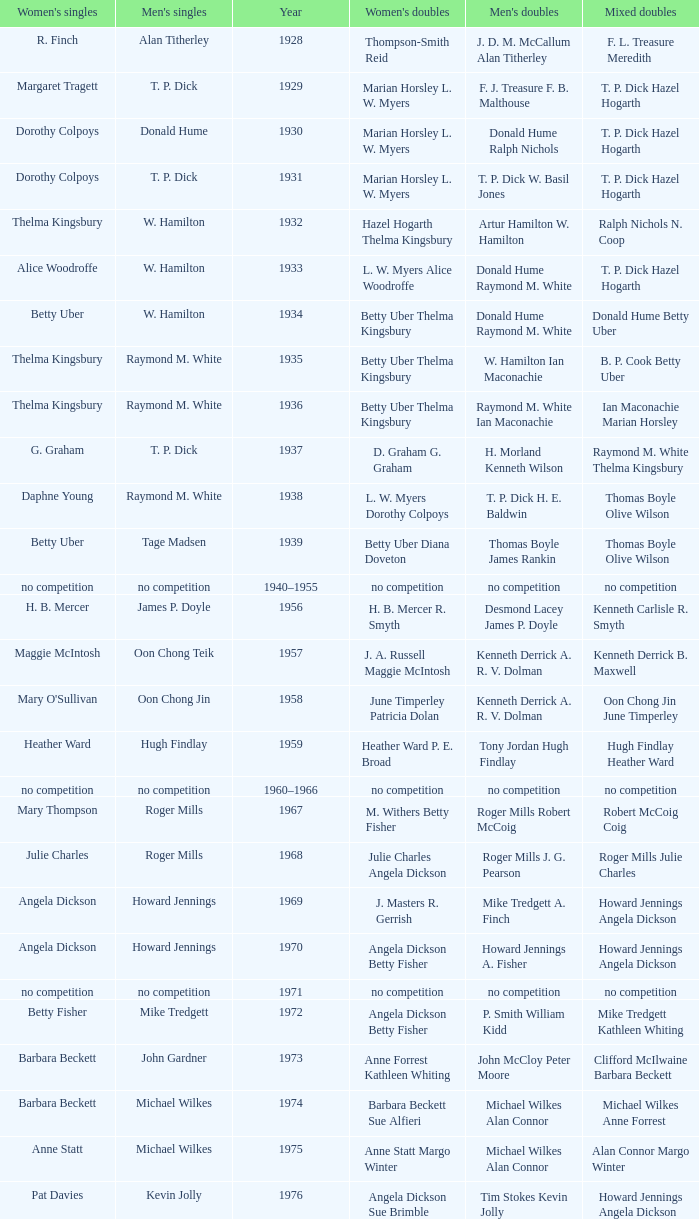Who won the Women's doubles in the year that David Eddy Eddy Sutton won the Men's doubles, and that David Eddy won the Men's singles? Anne Statt Jane Webster. Could you help me parse every detail presented in this table? {'header': ["Women's singles", "Men's singles", 'Year', "Women's doubles", "Men's doubles", 'Mixed doubles'], 'rows': [['R. Finch', 'Alan Titherley', '1928', 'Thompson-Smith Reid', 'J. D. M. McCallum Alan Titherley', 'F. L. Treasure Meredith'], ['Margaret Tragett', 'T. P. Dick', '1929', 'Marian Horsley L. W. Myers', 'F. J. Treasure F. B. Malthouse', 'T. P. Dick Hazel Hogarth'], ['Dorothy Colpoys', 'Donald Hume', '1930', 'Marian Horsley L. W. Myers', 'Donald Hume Ralph Nichols', 'T. P. Dick Hazel Hogarth'], ['Dorothy Colpoys', 'T. P. Dick', '1931', 'Marian Horsley L. W. Myers', 'T. P. Dick W. Basil Jones', 'T. P. Dick Hazel Hogarth'], ['Thelma Kingsbury', 'W. Hamilton', '1932', 'Hazel Hogarth Thelma Kingsbury', 'Artur Hamilton W. Hamilton', 'Ralph Nichols N. Coop'], ['Alice Woodroffe', 'W. Hamilton', '1933', 'L. W. Myers Alice Woodroffe', 'Donald Hume Raymond M. White', 'T. P. Dick Hazel Hogarth'], ['Betty Uber', 'W. Hamilton', '1934', 'Betty Uber Thelma Kingsbury', 'Donald Hume Raymond M. White', 'Donald Hume Betty Uber'], ['Thelma Kingsbury', 'Raymond M. White', '1935', 'Betty Uber Thelma Kingsbury', 'W. Hamilton Ian Maconachie', 'B. P. Cook Betty Uber'], ['Thelma Kingsbury', 'Raymond M. White', '1936', 'Betty Uber Thelma Kingsbury', 'Raymond M. White Ian Maconachie', 'Ian Maconachie Marian Horsley'], ['G. Graham', 'T. P. Dick', '1937', 'D. Graham G. Graham', 'H. Morland Kenneth Wilson', 'Raymond M. White Thelma Kingsbury'], ['Daphne Young', 'Raymond M. White', '1938', 'L. W. Myers Dorothy Colpoys', 'T. P. Dick H. E. Baldwin', 'Thomas Boyle Olive Wilson'], ['Betty Uber', 'Tage Madsen', '1939', 'Betty Uber Diana Doveton', 'Thomas Boyle James Rankin', 'Thomas Boyle Olive Wilson'], ['no competition', 'no competition', '1940–1955', 'no competition', 'no competition', 'no competition'], ['H. B. Mercer', 'James P. Doyle', '1956', 'H. B. Mercer R. Smyth', 'Desmond Lacey James P. Doyle', 'Kenneth Carlisle R. Smyth'], ['Maggie McIntosh', 'Oon Chong Teik', '1957', 'J. A. Russell Maggie McIntosh', 'Kenneth Derrick A. R. V. Dolman', 'Kenneth Derrick B. Maxwell'], ["Mary O'Sullivan", 'Oon Chong Jin', '1958', 'June Timperley Patricia Dolan', 'Kenneth Derrick A. R. V. Dolman', 'Oon Chong Jin June Timperley'], ['Heather Ward', 'Hugh Findlay', '1959', 'Heather Ward P. E. Broad', 'Tony Jordan Hugh Findlay', 'Hugh Findlay Heather Ward'], ['no competition', 'no competition', '1960–1966', 'no competition', 'no competition', 'no competition'], ['Mary Thompson', 'Roger Mills', '1967', 'M. Withers Betty Fisher', 'Roger Mills Robert McCoig', 'Robert McCoig Coig'], ['Julie Charles', 'Roger Mills', '1968', 'Julie Charles Angela Dickson', 'Roger Mills J. G. Pearson', 'Roger Mills Julie Charles'], ['Angela Dickson', 'Howard Jennings', '1969', 'J. Masters R. Gerrish', 'Mike Tredgett A. Finch', 'Howard Jennings Angela Dickson'], ['Angela Dickson', 'Howard Jennings', '1970', 'Angela Dickson Betty Fisher', 'Howard Jennings A. Fisher', 'Howard Jennings Angela Dickson'], ['no competition', 'no competition', '1971', 'no competition', 'no competition', 'no competition'], ['Betty Fisher', 'Mike Tredgett', '1972', 'Angela Dickson Betty Fisher', 'P. Smith William Kidd', 'Mike Tredgett Kathleen Whiting'], ['Barbara Beckett', 'John Gardner', '1973', 'Anne Forrest Kathleen Whiting', 'John McCloy Peter Moore', 'Clifford McIlwaine Barbara Beckett'], ['Barbara Beckett', 'Michael Wilkes', '1974', 'Barbara Beckett Sue Alfieri', 'Michael Wilkes Alan Connor', 'Michael Wilkes Anne Forrest'], ['Anne Statt', 'Michael Wilkes', '1975', 'Anne Statt Margo Winter', 'Michael Wilkes Alan Connor', 'Alan Connor Margo Winter'], ['Pat Davies', 'Kevin Jolly', '1976', 'Angela Dickson Sue Brimble', 'Tim Stokes Kevin Jolly', 'Howard Jennings Angela Dickson'], ['Paula Kilvington', 'David Eddy', '1977', 'Anne Statt Jane Webster', 'David Eddy Eddy Sutton', 'David Eddy Barbara Giles'], ['Gillian Gilks', 'Mike Tredgett', '1978', 'Barbara Sutton Marjan Ridder', 'David Eddy Eddy Sutton', 'Elliot Stuart Gillian Gilks'], ['Nora Perry', 'Kevin Jolly', '1979', 'Barbara Sutton Nora Perry', 'Ray Stevens Mike Tredgett', 'Mike Tredgett Nora Perry'], ['Jane Webster', 'Thomas Kihlström', '1980', 'Jane Webster Karen Puttick', 'Thomas Kihlström Bengt Fröman', 'Billy Gilliland Karen Puttick'], ['Gillian Gilks', 'Ray Stevens', '1981', 'Gillian Gilks Paula Kilvington', 'Ray Stevens Mike Tredgett', 'Mike Tredgett Nora Perry'], ['Karen Bridge', 'Steve Baddeley', '1982', 'Karen Chapman Sally Podger', 'David Eddy Eddy Sutton', 'Billy Gilliland Karen Chapman'], ['Sally Podger', 'Steve Butler', '1983', 'Nora Perry Jane Webster', 'Mike Tredgett Dipak Tailor', 'Dipak Tailor Nora Perry'], ['Karen Beckman', 'Steve Butler', '1984', 'Helen Troke Karen Chapman', 'Mike Tredgett Martin Dew', 'Mike Tredgett Karen Chapman'], ['Charlotte Hattens', 'Morten Frost', '1985', 'Gillian Gilks Helen Troke', 'Billy Gilliland Dan Travers', 'Martin Dew Gillian Gilks'], ['Fiona Elliott', 'Darren Hall', '1986', 'Karen Beckman Sara Halsall', 'Martin Dew Dipak Tailor', 'Jesper Knudsen Nettie Nielsen'], ['Fiona Elliott', 'Darren Hall', '1987', 'Karen Beckman Sara Halsall', 'Martin Dew Darren Hall', 'Martin Dew Gillian Gilks'], ['Lee Jung-mi', 'Vimal Kumar', '1988', 'Fiona Elliott Sara Halsall', 'Richard Outterside Mike Brown', 'Martin Dew Gillian Gilks'], ['Bang Soo-hyun', 'Darren Hall', '1989', 'Karen Beckman Sara Sankey', 'Nick Ponting Dave Wright', 'Mike Brown Jillian Wallwork'], ['Joanne Muggeridge', 'Mathew Smith', '1990', 'Karen Chapman Sara Sankey', 'Nick Ponting Dave Wright', 'Dave Wright Claire Palmer'], ['Denyse Julien', 'Vimal Kumar', '1991', 'Cheryl Johnson Julie Bradbury', 'Nick Ponting Dave Wright', 'Nick Ponting Joanne Wright'], ['Fiona Smith', 'Wei Yan', '1992', 'Denyse Julien Doris Piché', 'Michael Adams Chris Rees', 'Andy Goode Joanne Wright'], ['Sue Louis Lane', 'Anders Nielsen', '1993', 'Julie Bradbury Sara Sankey', 'Nick Ponting Dave Wright', 'Nick Ponting Joanne Wright'], ['Marina Andrievskaya', 'Darren Hall', '1994', 'Julie Bradbury Joanne Wright', 'Michael Adams Simon Archer', 'Chris Hunt Joanne Wright'], ['Denyse Julien', 'Peter Rasmussen', '1995', 'Julie Bradbury Joanne Wright', 'Andrei Andropov Nikolai Zuyev', 'Nick Ponting Joanne Wright'], ['Elena Rybkina', 'Colin Haughton', '1996', 'Elena Rybkina Marina Yakusheva', 'Andrei Andropov Nikolai Zuyev', 'Nikolai Zuyev Marina Yakusheva'], ['Kelly Morgan', 'Chris Bruil', '1997', 'Nicole van Hooren Brenda Conijn', 'Ian Pearson James Anderson', 'Quinten van Dalm Nicole van Hooren'], ['Brenda Beenhakker', 'Dicky Palyama', '1998', 'Sara Sankey Ella Tripp', 'James Anderson Ian Sullivan', 'James Anderson Sara Sankey'], ['Marina Andrievskaya', 'Daniel Eriksson', '1999', 'Marina Andrievskaya Catrine Bengtsson', 'Joachim Tesche Jean-Philippe Goyette', 'Henrik Andersson Marina Andrievskaya'], ['Marina Yakusheva', 'Richard Vaughan', '2000', 'Irina Ruslyakova Marina Yakusheva', 'Joachim Andersson Peter Axelsson', 'Peter Jeffrey Joanne Davies'], ['Brenda Beenhakker', 'Irwansyah', '2001', 'Sara Sankey Ella Tripp', 'Vincent Laigle Svetoslav Stoyanov', 'Nikolai Zuyev Marina Yakusheva'], ['Karina de Wit', 'Irwansyah', '2002', 'Ella Tripp Joanne Wright', 'Nikolai Zuyev Stanislav Pukhov', 'Nikolai Zuyev Marina Yakusheva'], ['Ella Karachkova', 'Irwansyah', '2003', 'Ella Karachkova Anastasia Russkikh', 'Ashley Thilthorpe Kristian Roebuck', 'Alexandr Russkikh Anastasia Russkikh'], ['Petya Nedelcheva', 'Nathan Rice', '2004', 'Petya Nedelcheva Yuan Wemyss', 'Reuben Gordown Aji Basuki Sindoro', 'Matthew Hughes Kelly Morgan'], ['Eleanor Cox', 'Chetan Anand', '2005', 'Hayley Connor Heather Olver', 'Andrew Ellis Dean George', 'Valiyaveetil Diju Jwala Gutta'], ['Huang Chia-chi', 'Irwansyah', '2006', 'Natalie Munt Mariana Agathangelou', 'Matthew Hughes Martyn Lewis', 'Kristian Roebuck Natalie Munt'], ['Jill Pittard', 'Marc Zwiebler', '2007', 'Chloe Magee Bing Huang', 'Wojciech Szkudlarczyk Adam Cwalina', 'Wojciech Szkudlarczyk Malgorzata Kurdelska'], ['Kati Tolmoff', 'Brice Leverdez', '2008', 'Mariana Agathangelou Jillie Cooper', 'Andrew Bowman Martyn Lewis', 'Watson Briggs Jillie Cooper'], ['Tatjana Bibik', 'Kristian Nielsen', '2009', 'Valeria Sorokina Nina Vislova', 'Vitaliy Durkin Alexandr Nikolaenko', 'Vitaliy Durkin Nina Vislova'], ['Anita Raj Kaur', 'Pablo Abián', '2010', 'Joanne Quay Swee Ling Anita Raj Kaur', 'Peter Käsbauer Josche Zurwonne', 'Peter Käsbauer Johanna Goliszewski'], ['Nicole Schaller', 'Niluka Karunaratne', '2011', 'Ng Hui Ern Ng Hui Lin', 'Chris Coles Matthew Nottingham', 'Martin Campbell Ng Hui Lin'], ['Chiang Mei-hui', 'Chou Tien-chen', '2012', 'Gabrielle White Lauren Smith', 'Marcus Ellis Paul Van Rietvelde', 'Marcus Ellis Gabrielle White']]} 